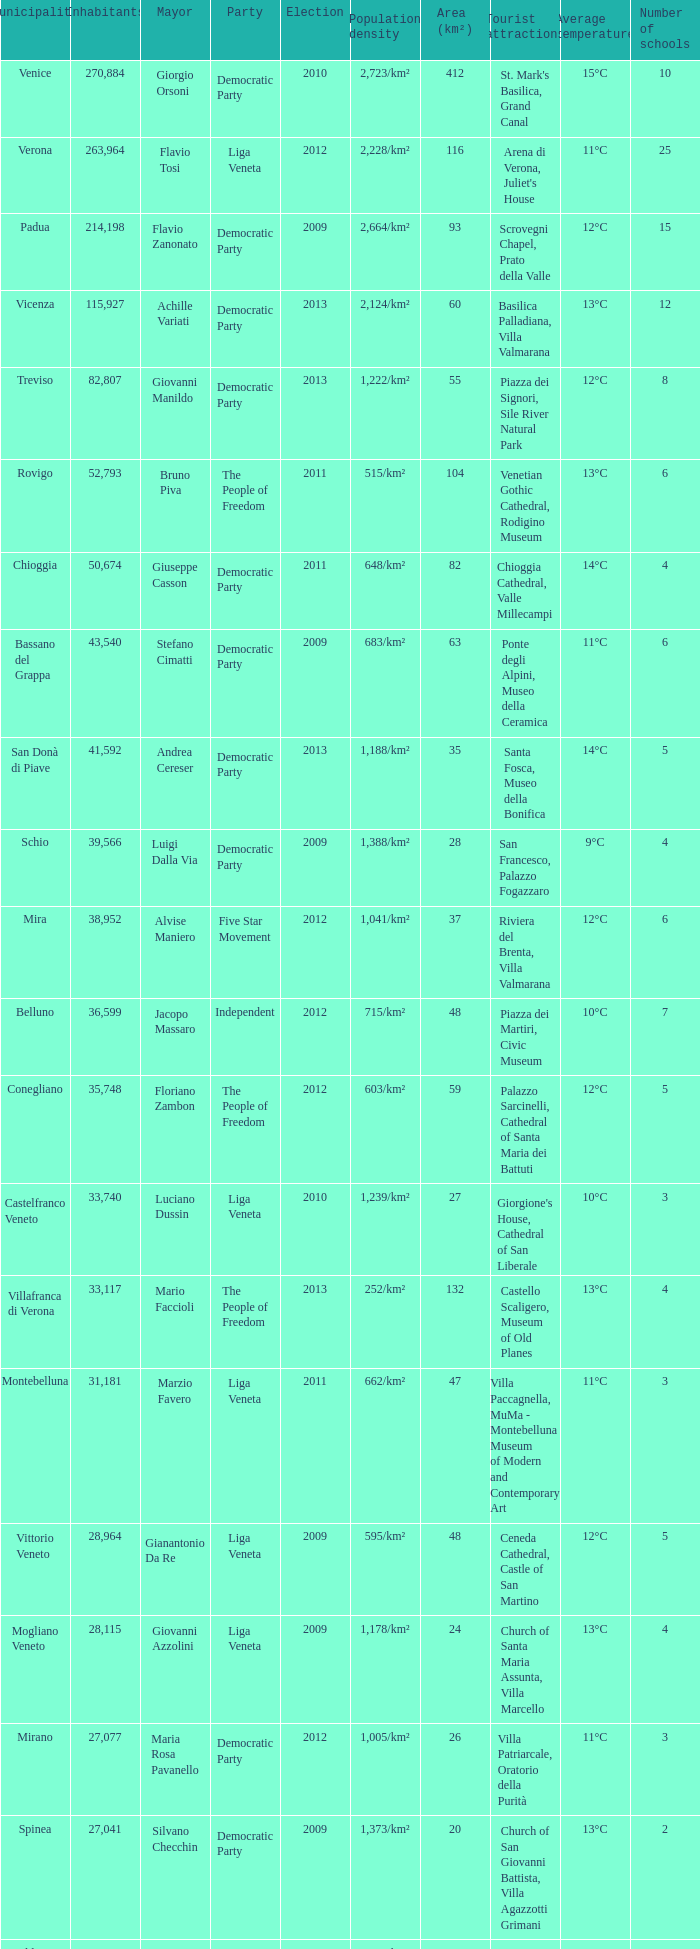Would you be able to parse every entry in this table? {'header': ['Municipality', 'Inhabitants', 'Mayor', 'Party', 'Election', 'Population density', 'Area (km²)', 'Tourist attractions', 'Average temperature', 'Number of schools'], 'rows': [['Venice', '270,884', 'Giorgio Orsoni', 'Democratic Party', '2010', '2,723/km²', '412', "St. Mark's Basilica, Grand Canal", '15°C', '10'], ['Verona', '263,964', 'Flavio Tosi', 'Liga Veneta', '2012', '2,228/km²', '116', "Arena di Verona, Juliet's House", '11°C', '25'], ['Padua', '214,198', 'Flavio Zanonato', 'Democratic Party', '2009', '2,664/km²', '93', 'Scrovegni Chapel, Prato della Valle', '12°C', '15'], ['Vicenza', '115,927', 'Achille Variati', 'Democratic Party', '2013', '2,124/km²', '60', 'Basilica Palladiana, Villa Valmarana', '13°C', '12'], ['Treviso', '82,807', 'Giovanni Manildo', 'Democratic Party', '2013', '1,222/km²', '55', 'Piazza dei Signori, Sile River Natural Park', '12°C', '8'], ['Rovigo', '52,793', 'Bruno Piva', 'The People of Freedom', '2011', '515/km²', '104', 'Venetian Gothic Cathedral, Rodigino Museum', '13°C', '6'], ['Chioggia', '50,674', 'Giuseppe Casson', 'Democratic Party', '2011', '648/km²', '82', 'Chioggia Cathedral, Valle Millecampi', '14°C', '4'], ['Bassano del Grappa', '43,540', 'Stefano Cimatti', 'Democratic Party', '2009', '683/km²', '63', 'Ponte degli Alpini, Museo della Ceramica', '11°C', '6'], ['San Donà di Piave', '41,592', 'Andrea Cereser', 'Democratic Party', '2013', '1,188/km²', '35', 'Santa Fosca, Museo della Bonifica', '14°C', '5'], ['Schio', '39,566', 'Luigi Dalla Via', 'Democratic Party', '2009', '1,388/km²', '28', 'San Francesco, Palazzo Fogazzaro', '9°C', '4'], ['Mira', '38,952', 'Alvise Maniero', 'Five Star Movement', '2012', '1,041/km²', '37', 'Riviera del Brenta, Villa Valmarana', '12°C', '6'], ['Belluno', '36,599', 'Jacopo Massaro', 'Independent', '2012', '715/km²', '48', 'Piazza dei Martiri, Civic Museum', '10°C', '7'], ['Conegliano', '35,748', 'Floriano Zambon', 'The People of Freedom', '2012', '603/km²', '59', 'Palazzo Sarcinelli, Cathedral of Santa Maria dei Battuti', '12°C', '5'], ['Castelfranco Veneto', '33,740', 'Luciano Dussin', 'Liga Veneta', '2010', '1,239/km²', '27', "Giorgione's House, Cathedral of San Liberale", '10°C', '3'], ['Villafranca di Verona', '33,117', 'Mario Faccioli', 'The People of Freedom', '2013', '252/km²', '132', 'Castello Scaligero, Museum of Old Planes', '13°C', '4'], ['Montebelluna', '31,181', 'Marzio Favero', 'Liga Veneta', '2011', '662/km²', '47', 'Villa Paccagnella, MuMa - Montebelluna Museum of Modern and Contemporary Art', '11°C', '3'], ['Vittorio Veneto', '28,964', 'Gianantonio Da Re', 'Liga Veneta', '2009', '595/km²', '48', 'Ceneda Cathedral, Castle of San Martino', '12°C', '5'], ['Mogliano Veneto', '28,115', 'Giovanni Azzolini', 'Liga Veneta', '2009', '1,178/km²', '24', 'Church of Santa Maria Assunta, Villa Marcello', '13°C', '4'], ['Mirano', '27,077', 'Maria Rosa Pavanello', 'Democratic Party', '2012', '1,005/km²', '26', 'Villa Patriarcale, Oratorio della Purità', '11°C', '3'], ['Spinea', '27,041', 'Silvano Checchin', 'Democratic Party', '2009', '1,373/km²', '20', 'Church of San Giovanni Battista, Villa Agazzotti Grimani', '13°C', '2'], ['Valdagno', '26,889', 'Alberto Neri', 'Democratic Party', '2009', '1,604/km²', '17', 'Sanctuary of the Madonna di Lourdes, Musil', '10°C', '3'], ['Arzignano', '26,046', 'Giorgio Gentilin', 'The People of Freedom', '2009', '1,020/km²', '26', "Museo dell'Ombrello e del Parasole, Santuario di San Magno", '12°C', '4'], ['Jesolo', '25,601', 'Valerio Zoggia', 'The People of Freedom', '2012', '387/km²', '93', 'Piazza Mazzini, Tropicarium Park', '14°C', '10'], ['Legnago', '25,600', 'Roberto Rettondini', 'Liga Veneta', '2009', '374/km²', '69', 'Castle of San Pietro, Museo della Guerra', '12°C', '4'], ['Portogruaro', '25,440', 'Antonio Bertoncello', 'Democratic Party', '2010', '566/km²', '54', 'Villa Comunale della Rose, Corso Martiri della Libertà', '12°C', '5']]} What party was achille variati afilliated with? Democratic Party. 